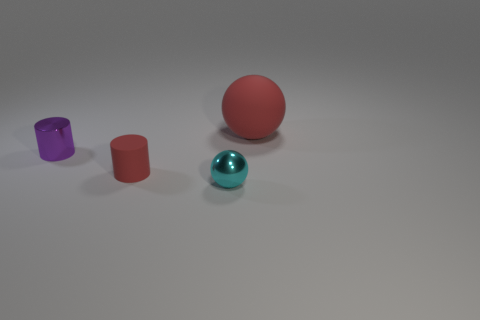The red cylinder is what size?
Your answer should be very brief. Small. There is another thing that is the same material as the tiny red thing; what is its size?
Give a very brief answer. Large. Is the size of the shiny object left of the metal sphere the same as the tiny rubber object?
Ensure brevity in your answer.  Yes. There is a small thing behind the small red matte cylinder that is in front of the object on the right side of the cyan shiny sphere; what is its shape?
Make the answer very short. Cylinder. How many objects are metallic balls or matte things to the left of the tiny cyan ball?
Provide a short and direct response. 2. How big is the metallic object on the left side of the tiny red cylinder?
Keep it short and to the point. Small. What is the shape of the small matte thing that is the same color as the big rubber thing?
Your response must be concise. Cylinder. Is the purple cylinder made of the same material as the red object in front of the large red ball?
Provide a short and direct response. No. How many red rubber spheres are behind the sphere that is to the left of the red thing that is on the right side of the cyan object?
Provide a short and direct response. 1. How many cyan objects are either big rubber balls or metal objects?
Provide a succinct answer. 1. 